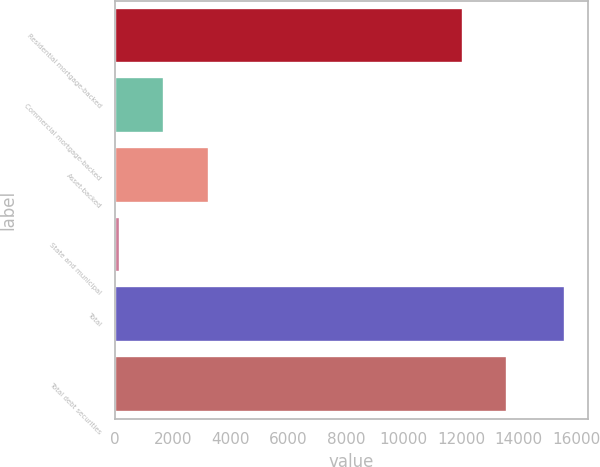Convert chart to OTSL. <chart><loc_0><loc_0><loc_500><loc_500><bar_chart><fcel>Residential mortgage-backed<fcel>Commercial mortgage-backed<fcel>Asset-backed<fcel>State and municipal<fcel>Total<fcel>Total debt securities<nl><fcel>12059<fcel>1707.3<fcel>3253.6<fcel>161<fcel>15624<fcel>13605.3<nl></chart> 